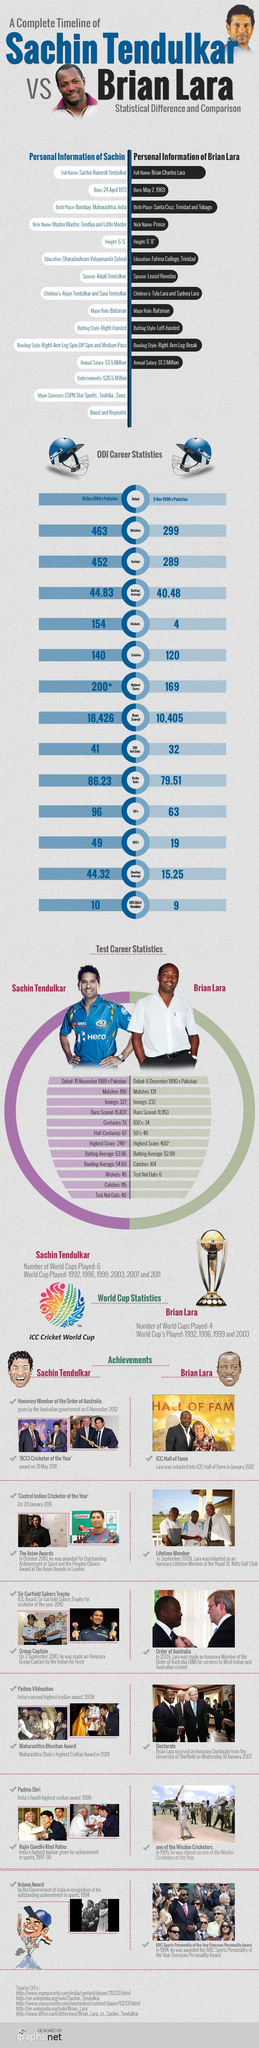Highlight a few significant elements in this photo. Sachin Tendulkar has a batting average of 44.83, which is an impressive achievement in the world of cricket. The combined total runs scored by Brian Lara and Sachin Tendulkar is 28,831. Sachin Tendulkar's height is 5'5". Brian Lara and Sachin Tendulkar both made their debuts in the same country: Pakistan. K. R. Narayanan, the former President of India, was awarded two prestigious awards, the Padma Shri and the Rajiv Gandhi Khel Ratna, for his exceptional service to the nation. 